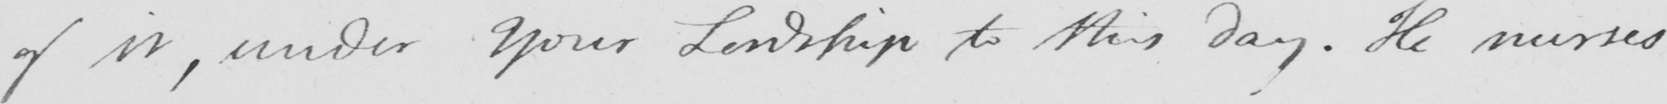What does this handwritten line say? of it , under Your Lordship to this day . He nurses 